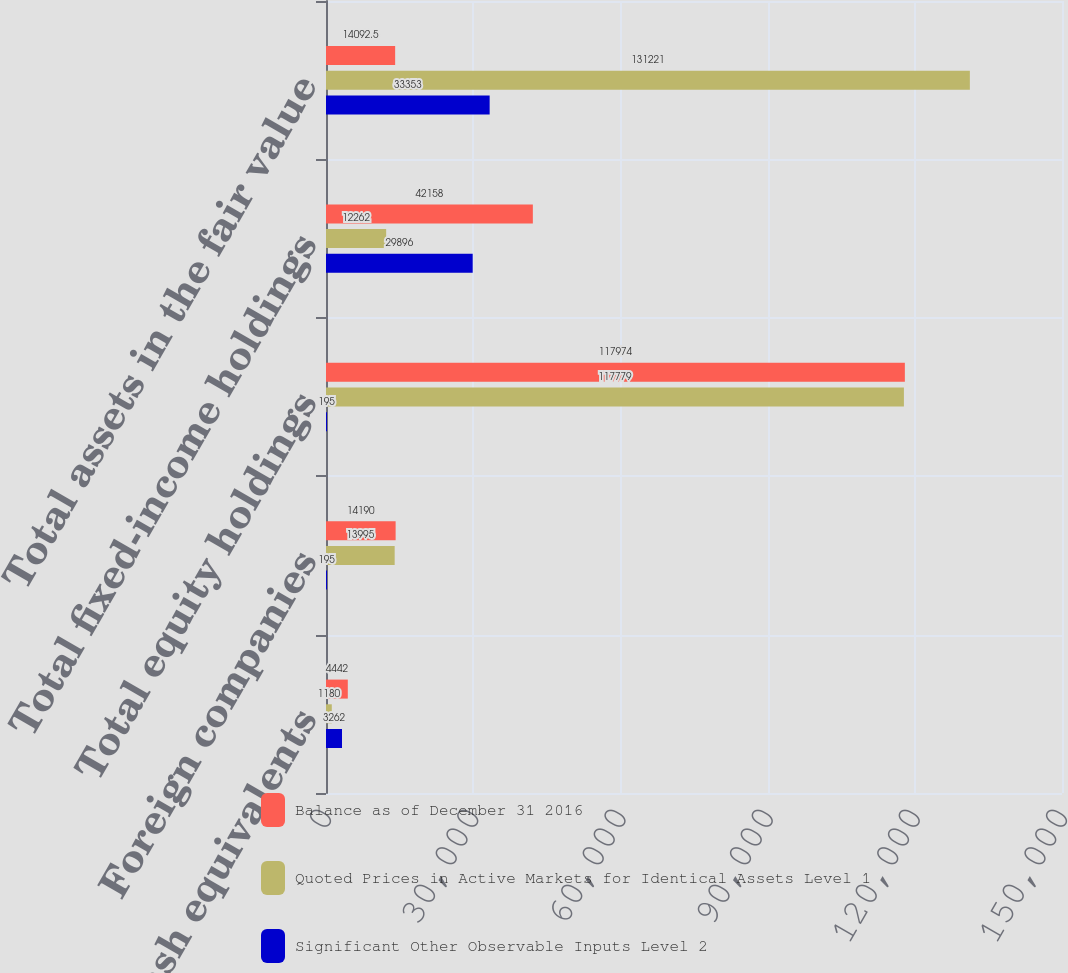<chart> <loc_0><loc_0><loc_500><loc_500><stacked_bar_chart><ecel><fcel>Cash and cash equivalents<fcel>Foreign companies<fcel>Total equity holdings<fcel>Total fixed-income holdings<fcel>Total assets in the fair value<nl><fcel>Balance as of December 31 2016<fcel>4442<fcel>14190<fcel>117974<fcel>42158<fcel>14092.5<nl><fcel>Quoted Prices in Active Markets for Identical Assets Level 1<fcel>1180<fcel>13995<fcel>117779<fcel>12262<fcel>131221<nl><fcel>Significant Other Observable Inputs Level 2<fcel>3262<fcel>195<fcel>195<fcel>29896<fcel>33353<nl></chart> 